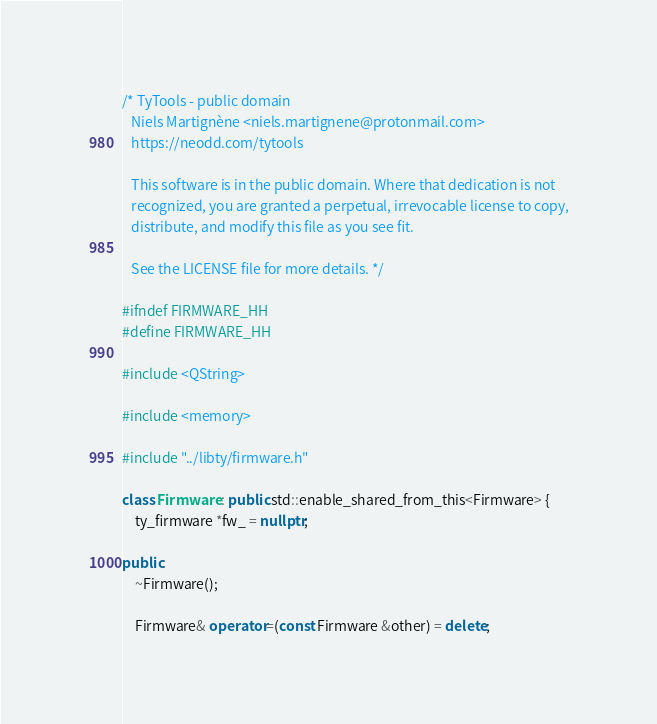<code> <loc_0><loc_0><loc_500><loc_500><_C++_>/* TyTools - public domain
   Niels Martignène <niels.martignene@protonmail.com>
   https://neodd.com/tytools

   This software is in the public domain. Where that dedication is not
   recognized, you are granted a perpetual, irrevocable license to copy,
   distribute, and modify this file as you see fit.

   See the LICENSE file for more details. */

#ifndef FIRMWARE_HH
#define FIRMWARE_HH

#include <QString>

#include <memory>

#include "../libty/firmware.h"

class Firmware : public std::enable_shared_from_this<Firmware> {
    ty_firmware *fw_ = nullptr;

public:
    ~Firmware();

    Firmware& operator=(const Firmware &other) = delete;</code> 